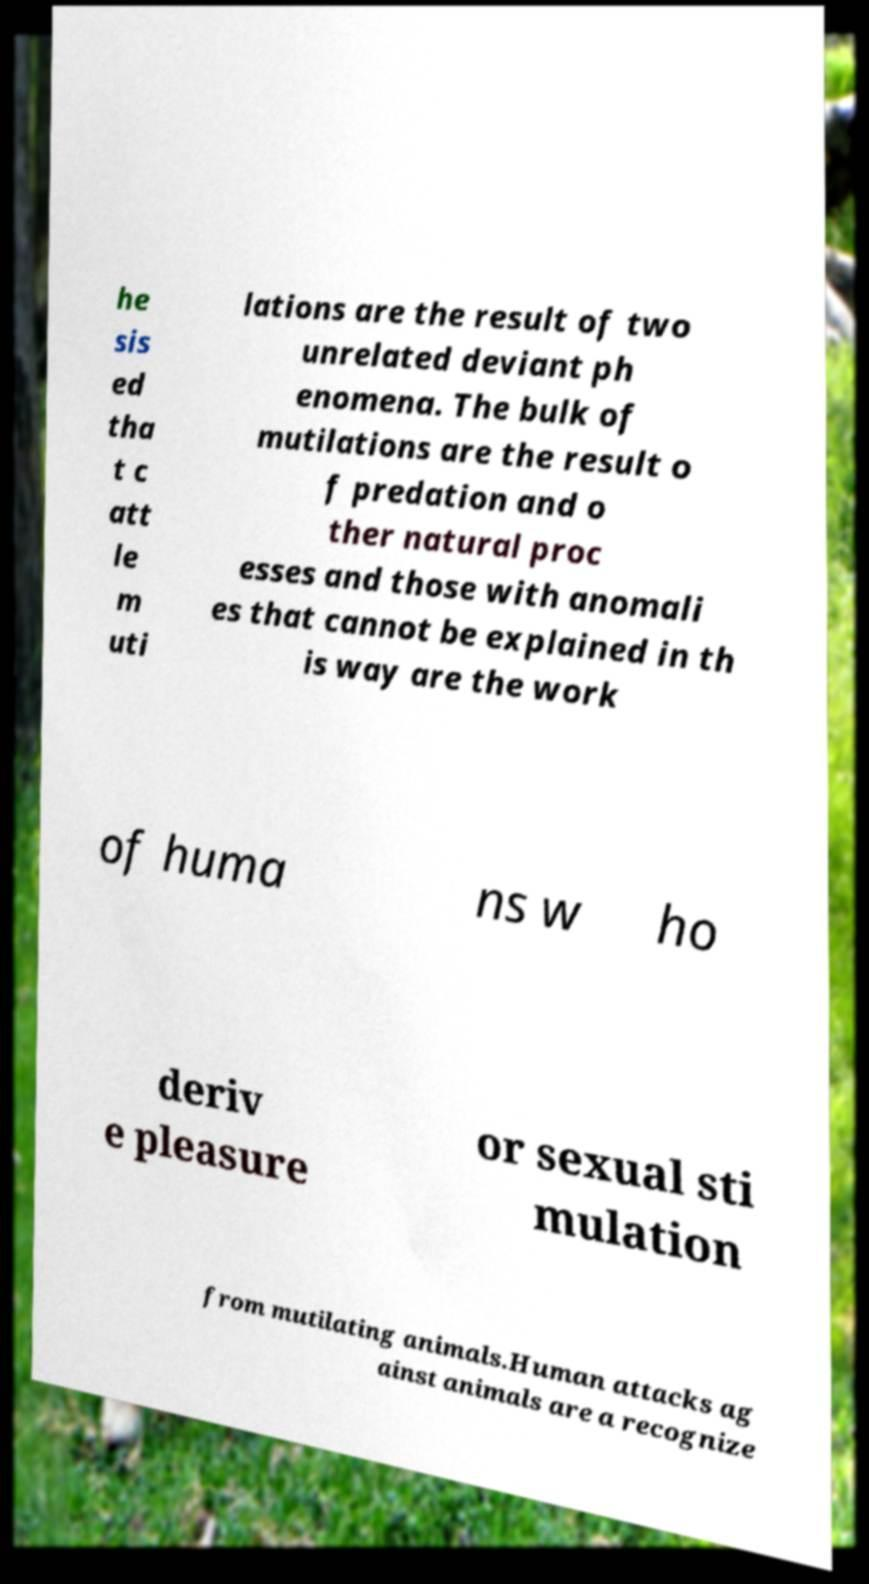Could you assist in decoding the text presented in this image and type it out clearly? he sis ed tha t c att le m uti lations are the result of two unrelated deviant ph enomena. The bulk of mutilations are the result o f predation and o ther natural proc esses and those with anomali es that cannot be explained in th is way are the work of huma ns w ho deriv e pleasure or sexual sti mulation from mutilating animals.Human attacks ag ainst animals are a recognize 